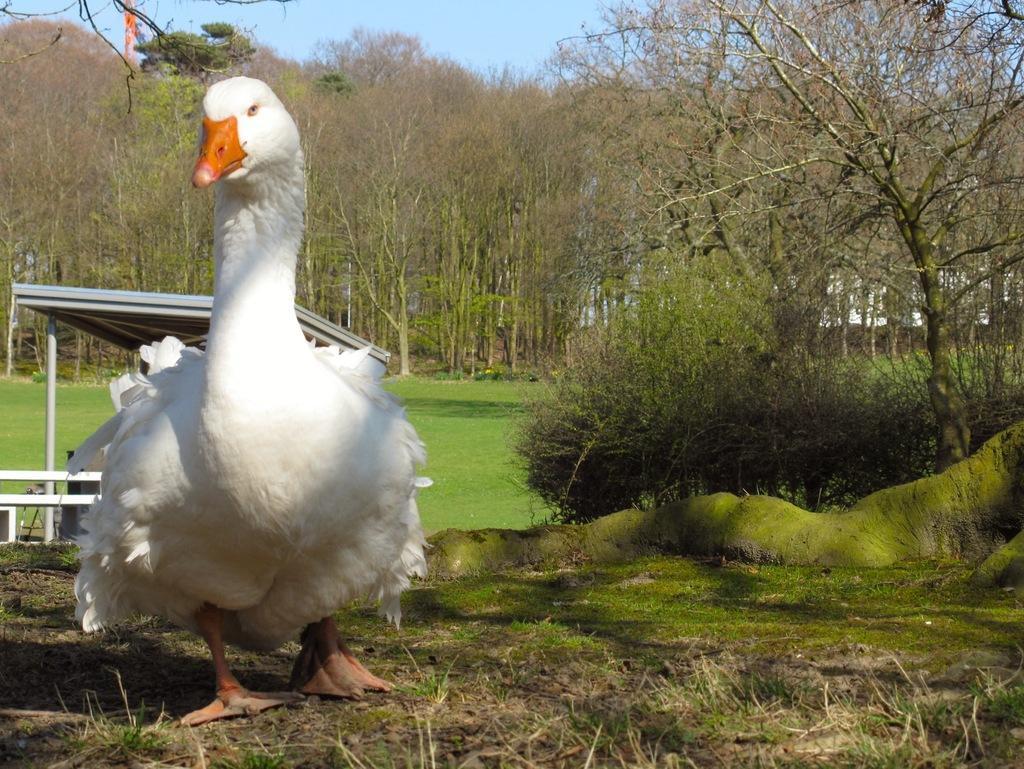Can you describe this image briefly? In this picture we can see a duck walking on the land , covered with grass and trees. 